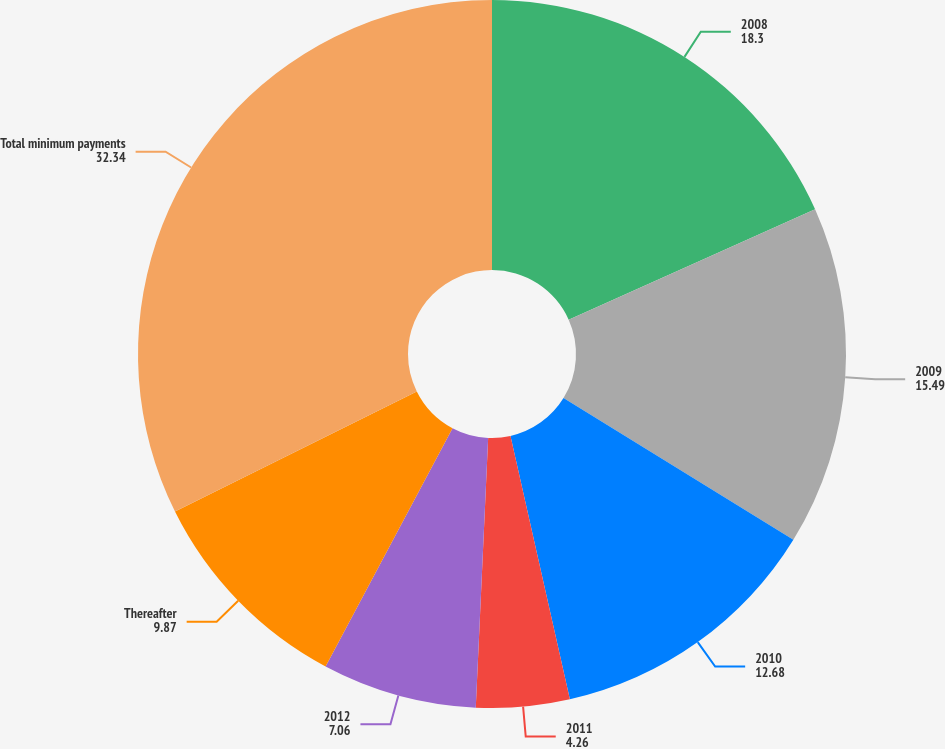Convert chart. <chart><loc_0><loc_0><loc_500><loc_500><pie_chart><fcel>2008<fcel>2009<fcel>2010<fcel>2011<fcel>2012<fcel>Thereafter<fcel>Total minimum payments<nl><fcel>18.3%<fcel>15.49%<fcel>12.68%<fcel>4.26%<fcel>7.06%<fcel>9.87%<fcel>32.34%<nl></chart> 